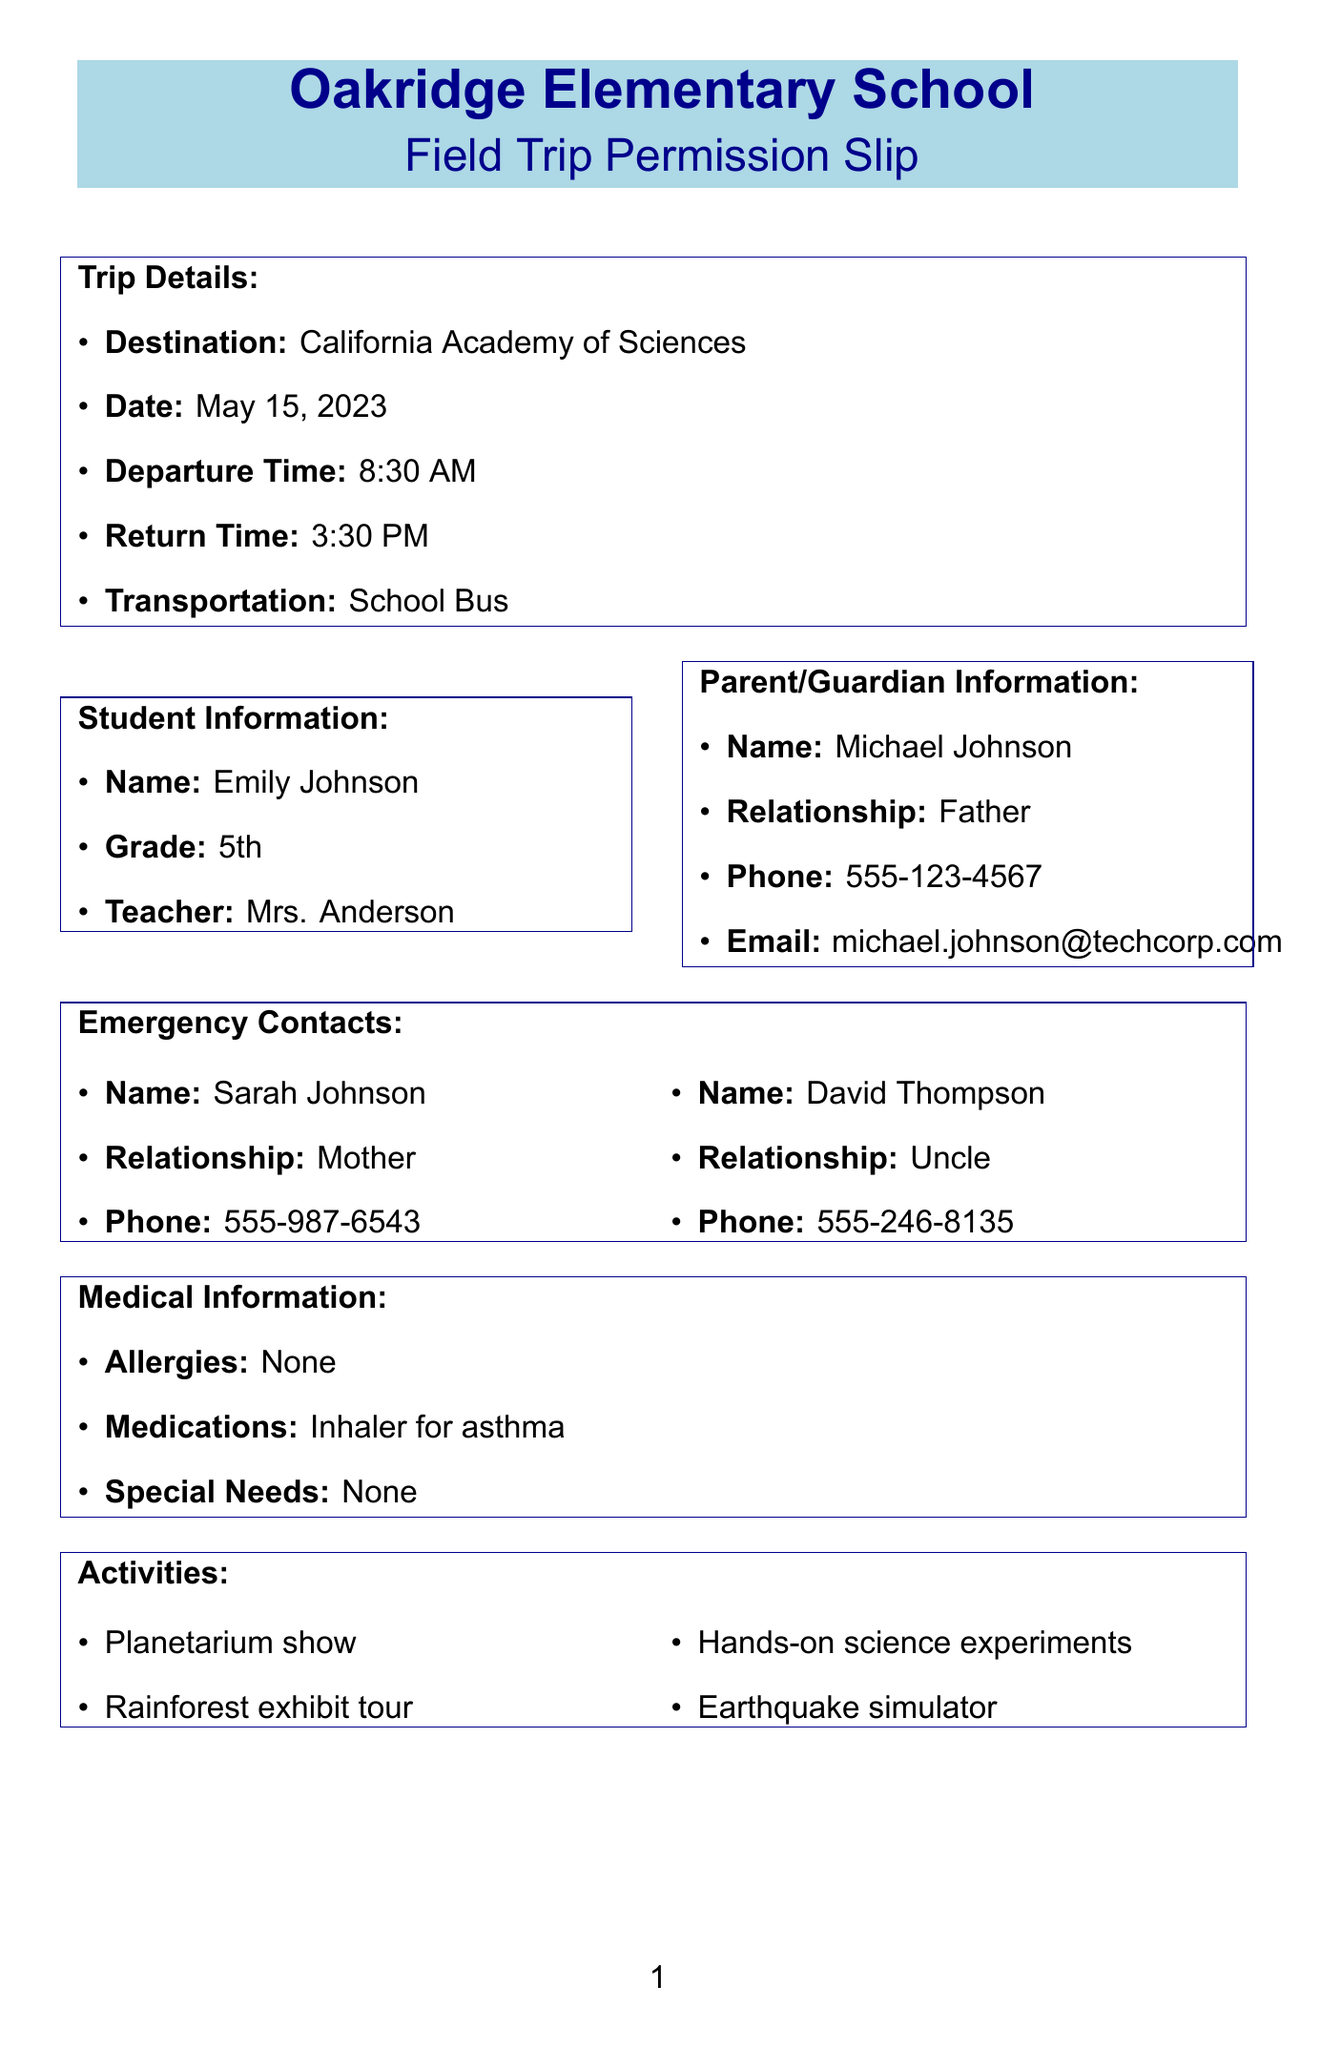what is the destination of the field trip? The destination is specified in the document under trip details.
Answer: California Academy of Sciences what is the departure time for the trip? The departure time is listed under the trip details section.
Answer: 8:30 AM who is the student's teacher? The teacher's name is provided under the student information section of the document.
Answer: Mrs. Anderson what is the amount due for the trip? The amount due is specified in the payment information section.
Answer: $25 how many emergency contacts are listed? The number of emergency contacts is stated in the document's emergency contacts section.
Answer: 2 which medical condition is mentioned for the student? The medical information section specifies the condition mentioned.
Answer: Asthma what type of activities are included in the field trip? The activities section lists the activities that will take place during the trip.
Answer: Planetarium show, Rainforest exhibit tour, Hands-on science experiments, Earthquake simulator what is the due date for the payment? The due date for the payment is provided in the payment information section of the document.
Answer: May 1, 2023 who should parents contact if they have questions? The teacher contact section specifies whom parents should reach out to for queries.
Answer: Mrs. Anderson 